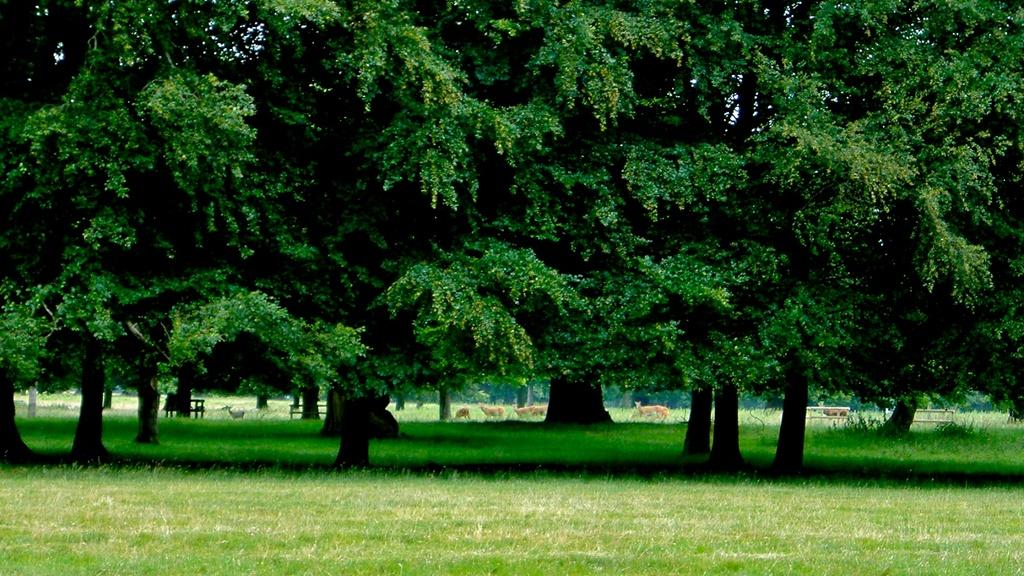What type of vegetation can be seen in the image? There are trees and grass in the image. What other elements are present in the image? There are animals and benches in the image. Can you describe the setting of the image? The image appears to be set in a park or outdoor area with trees, grass, benches, and animals. What is the father of the representative doing in the image? There is no father or representative present in the image. Can you tell me what the animals are writing in the image? Animals do not have the ability to write, and there is no writing present in the image. 